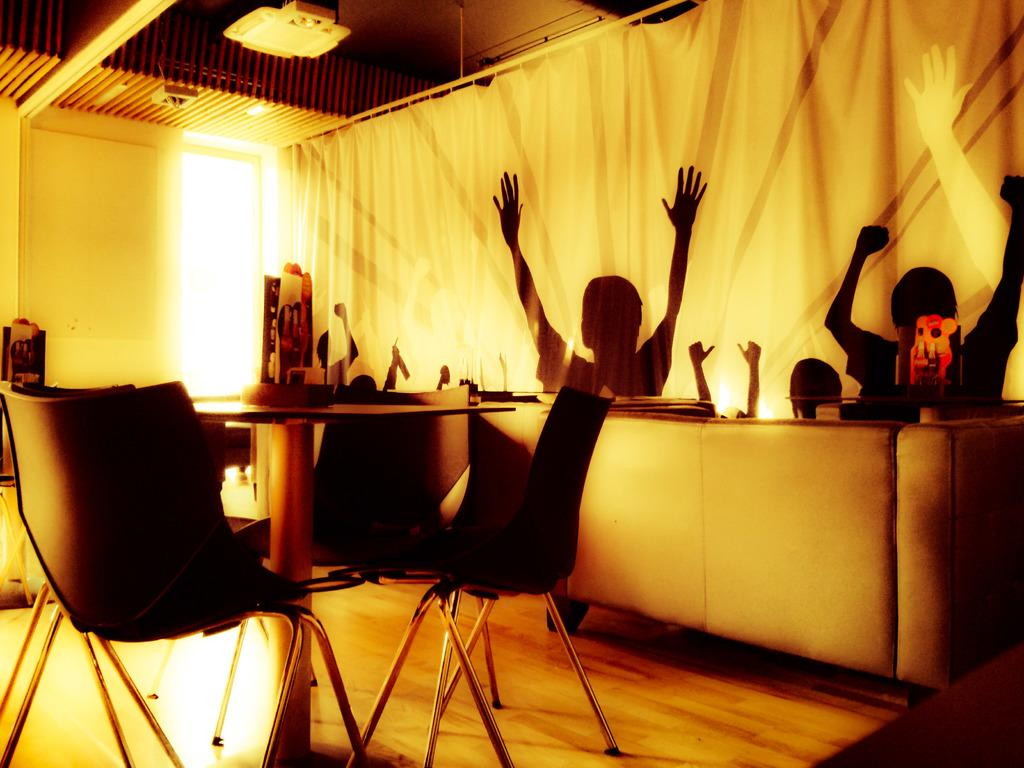What type of furniture is present in the image? There are chairs, a table, and a sofa in the image. What is the primary purpose of the table in the image? The table is likely used for placing items, as there are items on the table. Can you describe the arrangement of the furniture in the image? The chairs, table, and sofa are arranged in a way that suggests a seating area or living space. What type of tin can be seen being used for teaching in the image? There is no tin or teaching activity present in the image. 